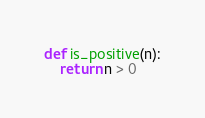Convert code to text. <code><loc_0><loc_0><loc_500><loc_500><_Python_>

def is_positive(n):
    return n > 0
</code> 